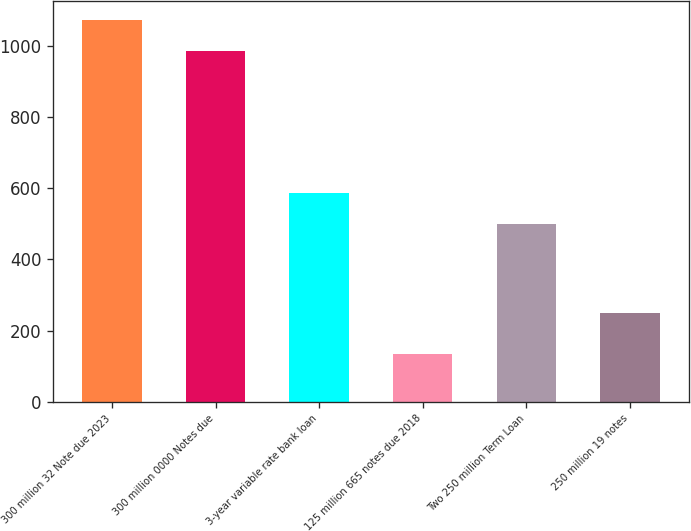<chart> <loc_0><loc_0><loc_500><loc_500><bar_chart><fcel>300 million 32 Note due 2023<fcel>300 million 0000 Notes due<fcel>3-year variable rate bank loan<fcel>125 million 665 notes due 2018<fcel>Two 250 million Term Loan<fcel>250 million 19 notes<nl><fcel>1072.9<fcel>987<fcel>587<fcel>133<fcel>500<fcel>250<nl></chart> 